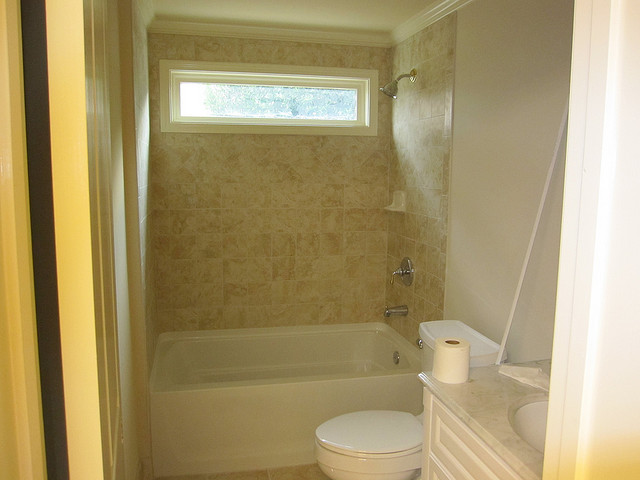How many people are wearing hat? 0 